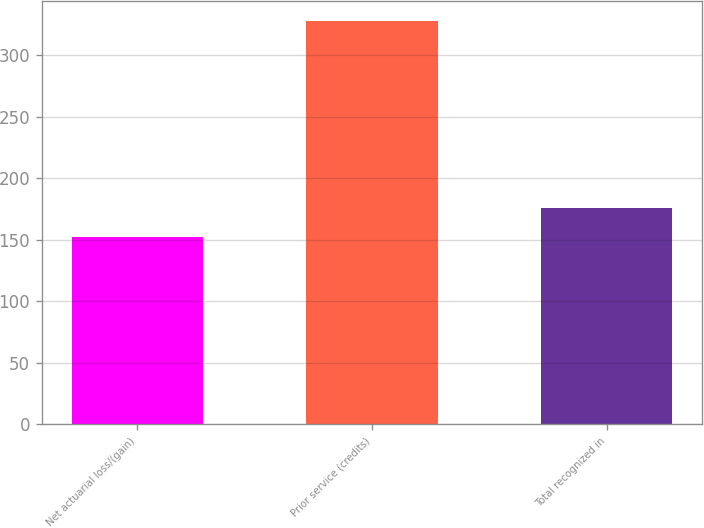Convert chart to OTSL. <chart><loc_0><loc_0><loc_500><loc_500><bar_chart><fcel>Net actuarial loss/(gain)<fcel>Prior service (credits)<fcel>Total recognized in<nl><fcel>152<fcel>328<fcel>176<nl></chart> 